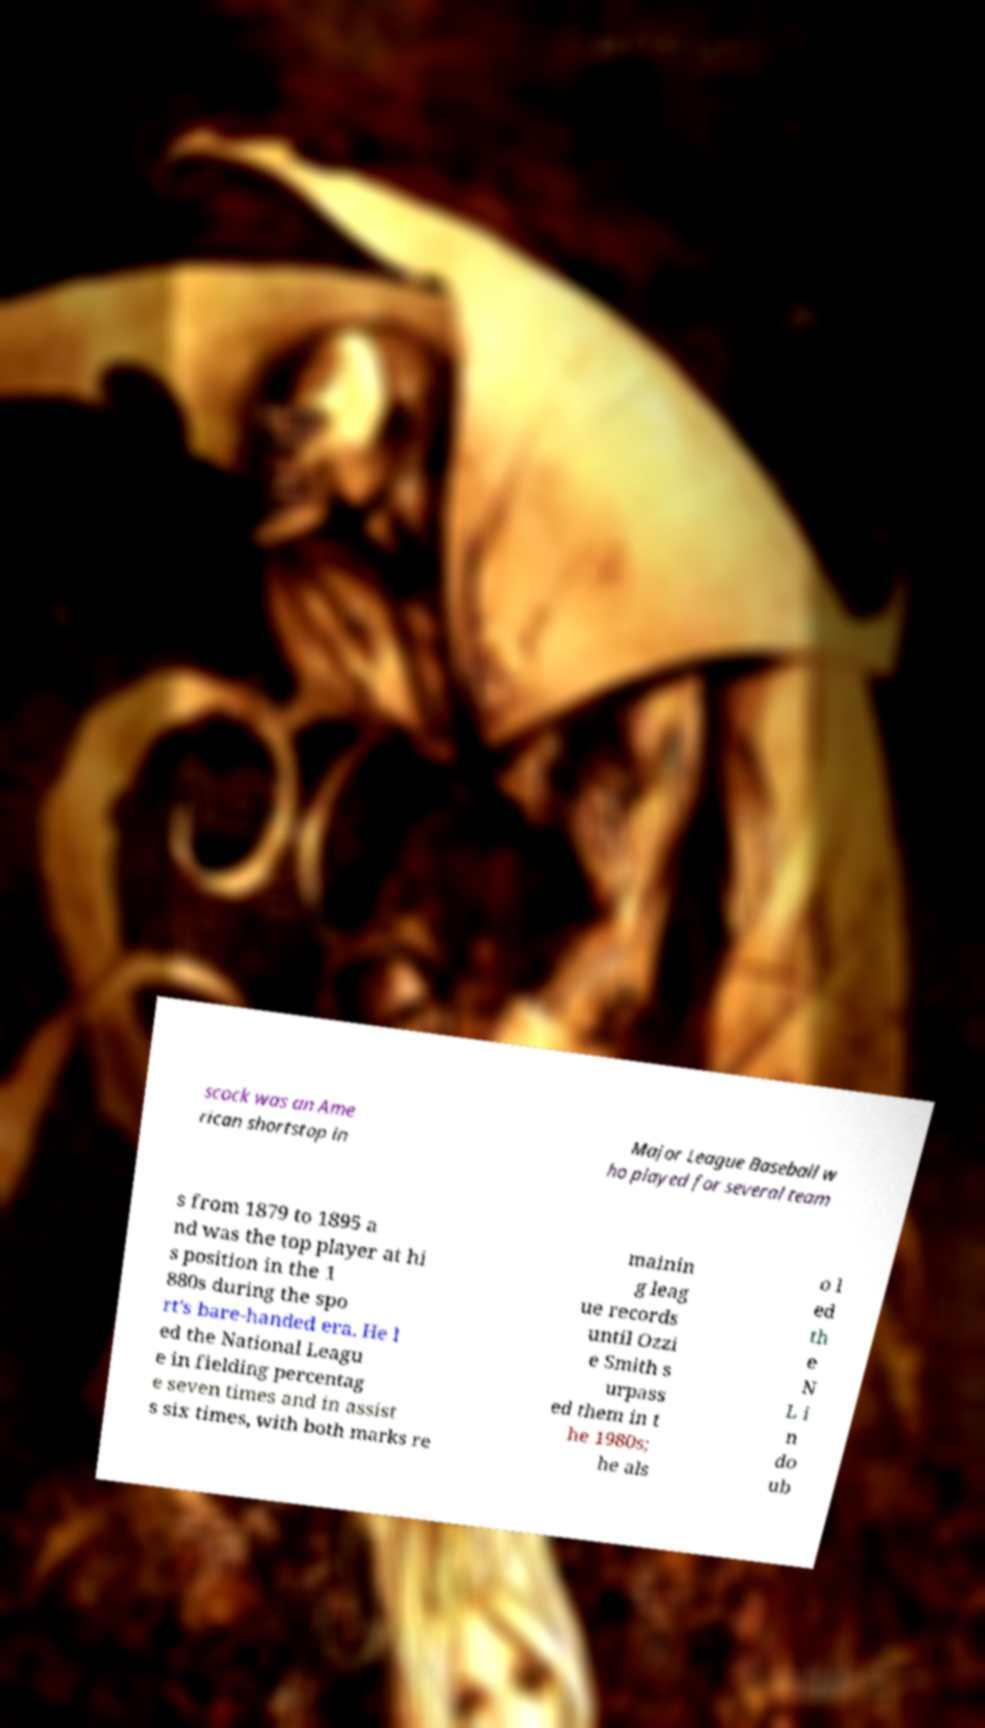Please identify and transcribe the text found in this image. scock was an Ame rican shortstop in Major League Baseball w ho played for several team s from 1879 to 1895 a nd was the top player at hi s position in the 1 880s during the spo rt's bare-handed era. He l ed the National Leagu e in fielding percentag e seven times and in assist s six times, with both marks re mainin g leag ue records until Ozzi e Smith s urpass ed them in t he 1980s; he als o l ed th e N L i n do ub 